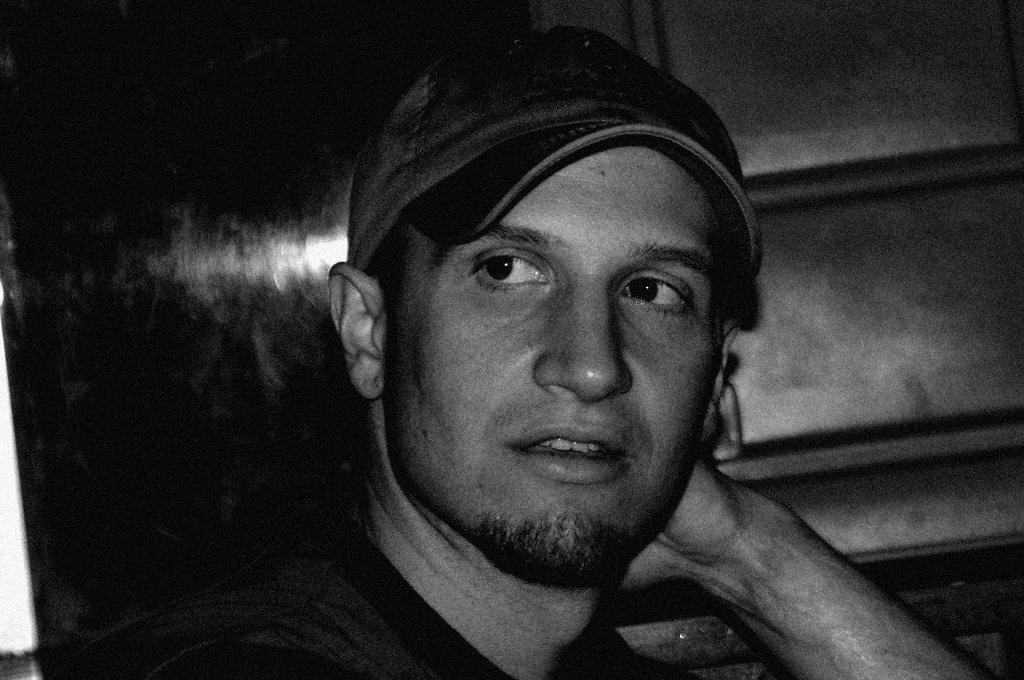What is the color scheme of the image? The image is black and white. How would you describe the background of the image? The background of the image is dark. Can you identify any person in the image? Yes, there is a man in the middle of the image. What is the man wearing on his head? The man is wearing a cap. What type of punishment is the man receiving in the image? There is no indication of punishment in the image; it only shows a man wearing a cap in a black and white, dark-background setting. 